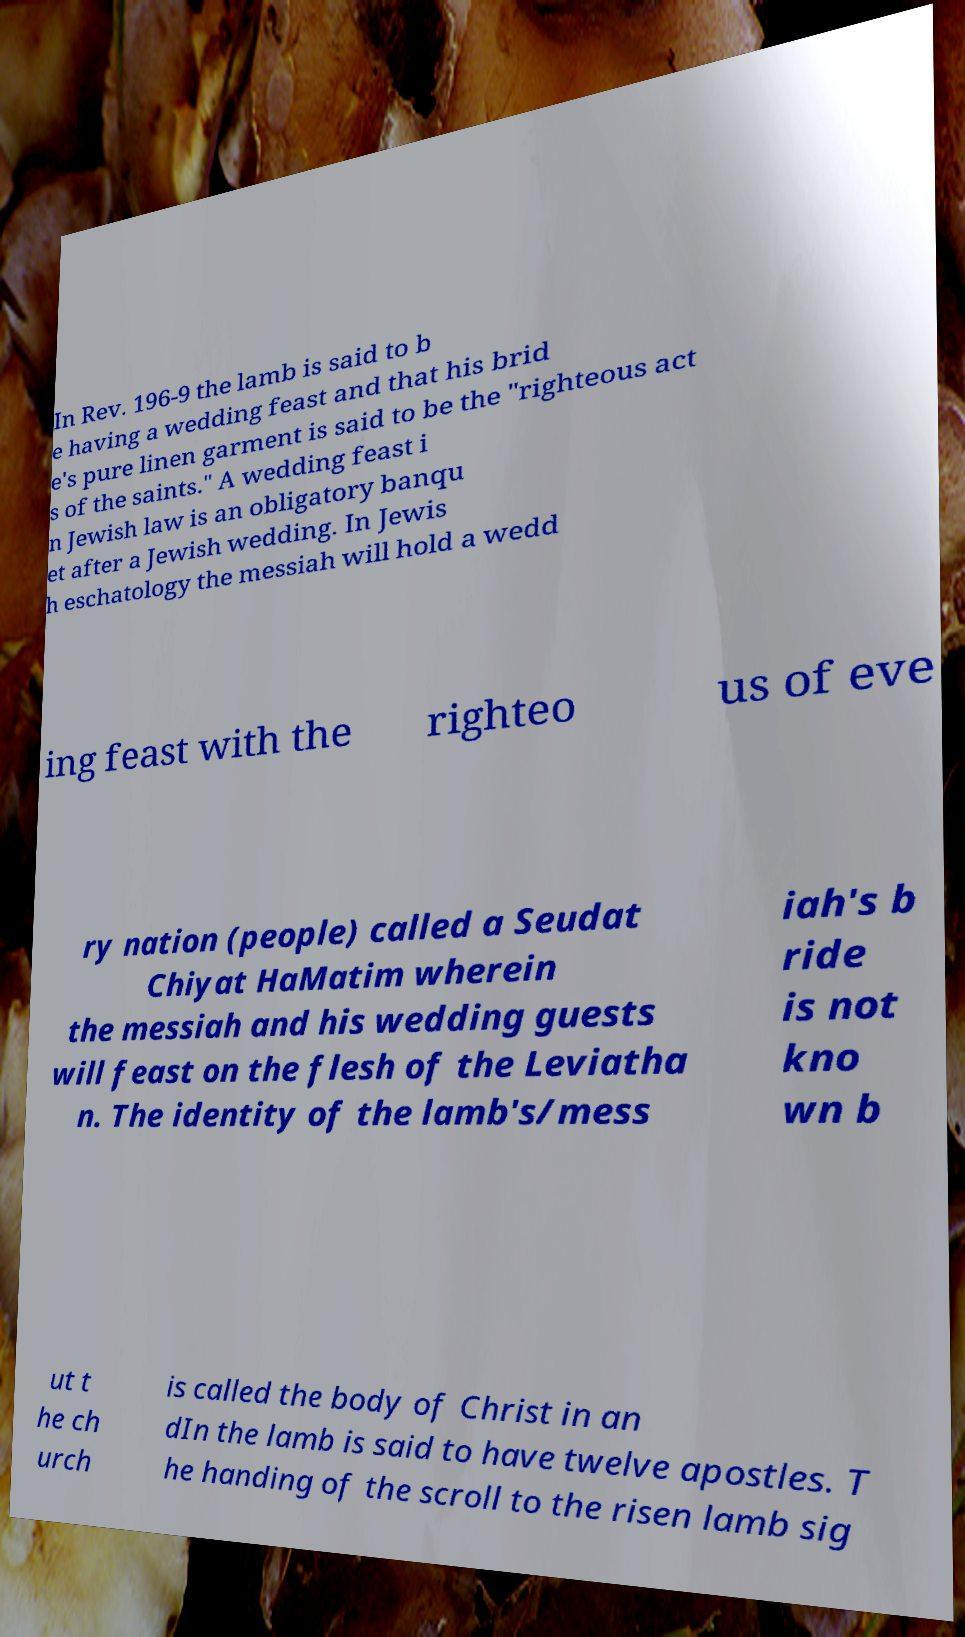Please read and relay the text visible in this image. What does it say? In Rev. 196-9 the lamb is said to b e having a wedding feast and that his brid e's pure linen garment is said to be the "righteous act s of the saints." A wedding feast i n Jewish law is an obligatory banqu et after a Jewish wedding. In Jewis h eschatology the messiah will hold a wedd ing feast with the righteo us of eve ry nation (people) called a Seudat Chiyat HaMatim wherein the messiah and his wedding guests will feast on the flesh of the Leviatha n. The identity of the lamb's/mess iah's b ride is not kno wn b ut t he ch urch is called the body of Christ in an dIn the lamb is said to have twelve apostles. T he handing of the scroll to the risen lamb sig 